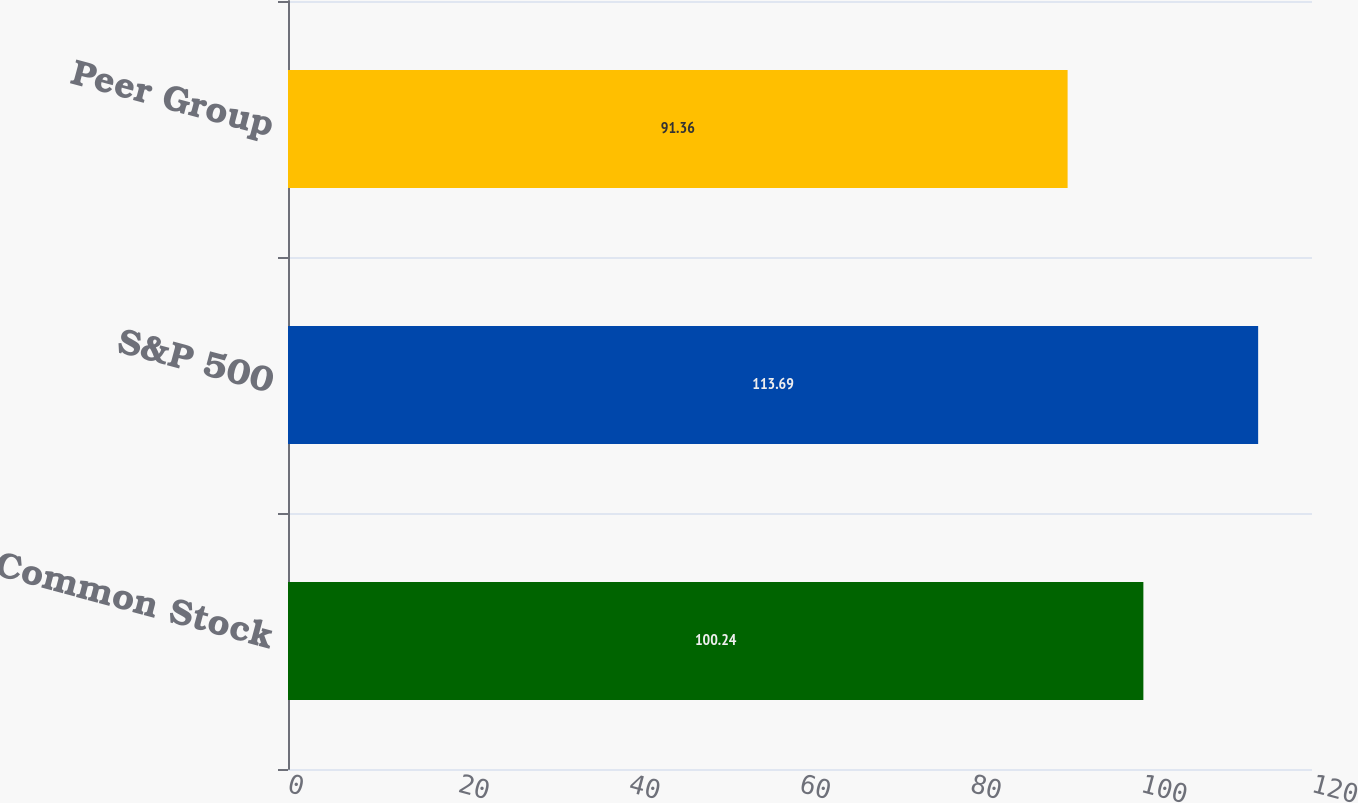Convert chart. <chart><loc_0><loc_0><loc_500><loc_500><bar_chart><fcel>Valero Common Stock<fcel>S&P 500<fcel>Peer Group<nl><fcel>100.24<fcel>113.69<fcel>91.36<nl></chart> 